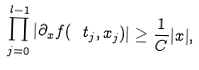<formula> <loc_0><loc_0><loc_500><loc_500>\prod _ { j = 0 } ^ { l - 1 } | \partial _ { x } f ( \ t _ { j } , x _ { j } ) | \geq \frac { 1 } { C } | x | ,</formula> 